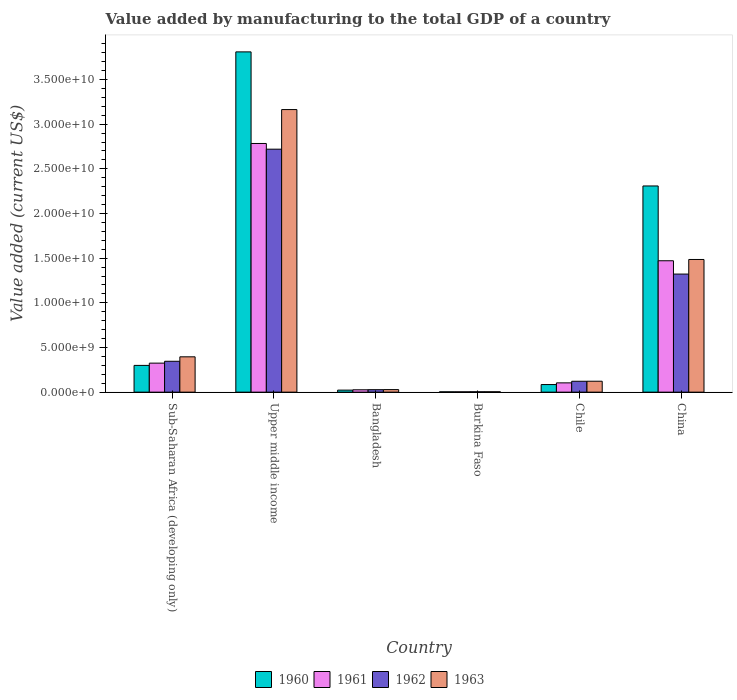How many bars are there on the 1st tick from the right?
Give a very brief answer. 4. What is the label of the 6th group of bars from the left?
Give a very brief answer. China. What is the value added by manufacturing to the total GDP in 1962 in Bangladesh?
Give a very brief answer. 2.77e+08. Across all countries, what is the maximum value added by manufacturing to the total GDP in 1960?
Your answer should be very brief. 3.81e+1. Across all countries, what is the minimum value added by manufacturing to the total GDP in 1963?
Offer a terse response. 4.39e+07. In which country was the value added by manufacturing to the total GDP in 1963 maximum?
Give a very brief answer. Upper middle income. In which country was the value added by manufacturing to the total GDP in 1963 minimum?
Make the answer very short. Burkina Faso. What is the total value added by manufacturing to the total GDP in 1962 in the graph?
Your answer should be very brief. 4.54e+1. What is the difference between the value added by manufacturing to the total GDP in 1960 in China and that in Upper middle income?
Your answer should be very brief. -1.50e+1. What is the difference between the value added by manufacturing to the total GDP in 1962 in Chile and the value added by manufacturing to the total GDP in 1961 in Burkina Faso?
Your answer should be compact. 1.18e+09. What is the average value added by manufacturing to the total GDP in 1960 per country?
Offer a terse response. 1.09e+1. What is the difference between the value added by manufacturing to the total GDP of/in 1960 and value added by manufacturing to the total GDP of/in 1962 in Bangladesh?
Provide a short and direct response. -4.99e+07. In how many countries, is the value added by manufacturing to the total GDP in 1961 greater than 21000000000 US$?
Keep it short and to the point. 1. What is the ratio of the value added by manufacturing to the total GDP in 1960 in Burkina Faso to that in China?
Your response must be concise. 0. Is the difference between the value added by manufacturing to the total GDP in 1960 in Chile and Upper middle income greater than the difference between the value added by manufacturing to the total GDP in 1962 in Chile and Upper middle income?
Your answer should be compact. No. What is the difference between the highest and the second highest value added by manufacturing to the total GDP in 1960?
Keep it short and to the point. 1.50e+1. What is the difference between the highest and the lowest value added by manufacturing to the total GDP in 1962?
Your answer should be compact. 2.72e+1. Is it the case that in every country, the sum of the value added by manufacturing to the total GDP in 1962 and value added by manufacturing to the total GDP in 1960 is greater than the sum of value added by manufacturing to the total GDP in 1961 and value added by manufacturing to the total GDP in 1963?
Your answer should be very brief. No. What does the 1st bar from the left in Bangladesh represents?
Offer a terse response. 1960. What does the 4th bar from the right in Chile represents?
Offer a terse response. 1960. How many bars are there?
Provide a succinct answer. 24. Are all the bars in the graph horizontal?
Provide a succinct answer. No. How many countries are there in the graph?
Keep it short and to the point. 6. What is the difference between two consecutive major ticks on the Y-axis?
Ensure brevity in your answer.  5.00e+09. Does the graph contain any zero values?
Offer a terse response. No. How are the legend labels stacked?
Offer a terse response. Horizontal. What is the title of the graph?
Your response must be concise. Value added by manufacturing to the total GDP of a country. What is the label or title of the X-axis?
Keep it short and to the point. Country. What is the label or title of the Y-axis?
Offer a very short reply. Value added (current US$). What is the Value added (current US$) of 1960 in Sub-Saharan Africa (developing only)?
Provide a succinct answer. 2.99e+09. What is the Value added (current US$) in 1961 in Sub-Saharan Africa (developing only)?
Offer a very short reply. 3.25e+09. What is the Value added (current US$) in 1962 in Sub-Saharan Africa (developing only)?
Make the answer very short. 3.46e+09. What is the Value added (current US$) of 1963 in Sub-Saharan Africa (developing only)?
Give a very brief answer. 3.95e+09. What is the Value added (current US$) of 1960 in Upper middle income?
Your answer should be very brief. 3.81e+1. What is the Value added (current US$) in 1961 in Upper middle income?
Ensure brevity in your answer.  2.78e+1. What is the Value added (current US$) in 1962 in Upper middle income?
Keep it short and to the point. 2.72e+1. What is the Value added (current US$) in 1963 in Upper middle income?
Make the answer very short. 3.16e+1. What is the Value added (current US$) of 1960 in Bangladesh?
Your answer should be compact. 2.27e+08. What is the Value added (current US$) of 1961 in Bangladesh?
Offer a very short reply. 2.64e+08. What is the Value added (current US$) of 1962 in Bangladesh?
Keep it short and to the point. 2.77e+08. What is the Value added (current US$) in 1963 in Bangladesh?
Keep it short and to the point. 2.85e+08. What is the Value added (current US$) in 1960 in Burkina Faso?
Offer a very short reply. 3.72e+07. What is the Value added (current US$) of 1961 in Burkina Faso?
Provide a succinct answer. 3.72e+07. What is the Value added (current US$) in 1962 in Burkina Faso?
Keep it short and to the point. 4.22e+07. What is the Value added (current US$) of 1963 in Burkina Faso?
Your answer should be compact. 4.39e+07. What is the Value added (current US$) in 1960 in Chile?
Provide a short and direct response. 8.51e+08. What is the Value added (current US$) of 1961 in Chile?
Your response must be concise. 1.04e+09. What is the Value added (current US$) of 1962 in Chile?
Ensure brevity in your answer.  1.22e+09. What is the Value added (current US$) of 1963 in Chile?
Your answer should be very brief. 1.22e+09. What is the Value added (current US$) in 1960 in China?
Offer a terse response. 2.31e+1. What is the Value added (current US$) of 1961 in China?
Your response must be concise. 1.47e+1. What is the Value added (current US$) in 1962 in China?
Give a very brief answer. 1.32e+1. What is the Value added (current US$) in 1963 in China?
Ensure brevity in your answer.  1.49e+1. Across all countries, what is the maximum Value added (current US$) in 1960?
Offer a very short reply. 3.81e+1. Across all countries, what is the maximum Value added (current US$) of 1961?
Give a very brief answer. 2.78e+1. Across all countries, what is the maximum Value added (current US$) of 1962?
Offer a very short reply. 2.72e+1. Across all countries, what is the maximum Value added (current US$) of 1963?
Offer a very short reply. 3.16e+1. Across all countries, what is the minimum Value added (current US$) in 1960?
Make the answer very short. 3.72e+07. Across all countries, what is the minimum Value added (current US$) in 1961?
Provide a succinct answer. 3.72e+07. Across all countries, what is the minimum Value added (current US$) of 1962?
Your answer should be very brief. 4.22e+07. Across all countries, what is the minimum Value added (current US$) in 1963?
Keep it short and to the point. 4.39e+07. What is the total Value added (current US$) of 1960 in the graph?
Offer a very short reply. 6.53e+1. What is the total Value added (current US$) in 1961 in the graph?
Provide a succinct answer. 4.71e+1. What is the total Value added (current US$) of 1962 in the graph?
Give a very brief answer. 4.54e+1. What is the total Value added (current US$) in 1963 in the graph?
Offer a terse response. 5.20e+1. What is the difference between the Value added (current US$) of 1960 in Sub-Saharan Africa (developing only) and that in Upper middle income?
Provide a short and direct response. -3.51e+1. What is the difference between the Value added (current US$) of 1961 in Sub-Saharan Africa (developing only) and that in Upper middle income?
Your response must be concise. -2.46e+1. What is the difference between the Value added (current US$) in 1962 in Sub-Saharan Africa (developing only) and that in Upper middle income?
Keep it short and to the point. -2.37e+1. What is the difference between the Value added (current US$) of 1963 in Sub-Saharan Africa (developing only) and that in Upper middle income?
Provide a short and direct response. -2.77e+1. What is the difference between the Value added (current US$) of 1960 in Sub-Saharan Africa (developing only) and that in Bangladesh?
Ensure brevity in your answer.  2.77e+09. What is the difference between the Value added (current US$) of 1961 in Sub-Saharan Africa (developing only) and that in Bangladesh?
Keep it short and to the point. 2.98e+09. What is the difference between the Value added (current US$) of 1962 in Sub-Saharan Africa (developing only) and that in Bangladesh?
Your answer should be very brief. 3.18e+09. What is the difference between the Value added (current US$) in 1963 in Sub-Saharan Africa (developing only) and that in Bangladesh?
Keep it short and to the point. 3.67e+09. What is the difference between the Value added (current US$) in 1960 in Sub-Saharan Africa (developing only) and that in Burkina Faso?
Keep it short and to the point. 2.96e+09. What is the difference between the Value added (current US$) in 1961 in Sub-Saharan Africa (developing only) and that in Burkina Faso?
Provide a short and direct response. 3.21e+09. What is the difference between the Value added (current US$) of 1962 in Sub-Saharan Africa (developing only) and that in Burkina Faso?
Provide a short and direct response. 3.41e+09. What is the difference between the Value added (current US$) in 1963 in Sub-Saharan Africa (developing only) and that in Burkina Faso?
Keep it short and to the point. 3.91e+09. What is the difference between the Value added (current US$) of 1960 in Sub-Saharan Africa (developing only) and that in Chile?
Provide a succinct answer. 2.14e+09. What is the difference between the Value added (current US$) of 1961 in Sub-Saharan Africa (developing only) and that in Chile?
Offer a terse response. 2.21e+09. What is the difference between the Value added (current US$) of 1962 in Sub-Saharan Africa (developing only) and that in Chile?
Provide a short and direct response. 2.24e+09. What is the difference between the Value added (current US$) in 1963 in Sub-Saharan Africa (developing only) and that in Chile?
Keep it short and to the point. 2.73e+09. What is the difference between the Value added (current US$) of 1960 in Sub-Saharan Africa (developing only) and that in China?
Offer a very short reply. -2.01e+1. What is the difference between the Value added (current US$) in 1961 in Sub-Saharan Africa (developing only) and that in China?
Your answer should be compact. -1.15e+1. What is the difference between the Value added (current US$) in 1962 in Sub-Saharan Africa (developing only) and that in China?
Offer a very short reply. -9.76e+09. What is the difference between the Value added (current US$) of 1963 in Sub-Saharan Africa (developing only) and that in China?
Give a very brief answer. -1.09e+1. What is the difference between the Value added (current US$) in 1960 in Upper middle income and that in Bangladesh?
Offer a very short reply. 3.79e+1. What is the difference between the Value added (current US$) in 1961 in Upper middle income and that in Bangladesh?
Offer a very short reply. 2.76e+1. What is the difference between the Value added (current US$) in 1962 in Upper middle income and that in Bangladesh?
Offer a very short reply. 2.69e+1. What is the difference between the Value added (current US$) in 1963 in Upper middle income and that in Bangladesh?
Make the answer very short. 3.13e+1. What is the difference between the Value added (current US$) in 1960 in Upper middle income and that in Burkina Faso?
Offer a terse response. 3.81e+1. What is the difference between the Value added (current US$) in 1961 in Upper middle income and that in Burkina Faso?
Ensure brevity in your answer.  2.78e+1. What is the difference between the Value added (current US$) of 1962 in Upper middle income and that in Burkina Faso?
Your answer should be very brief. 2.72e+1. What is the difference between the Value added (current US$) of 1963 in Upper middle income and that in Burkina Faso?
Offer a very short reply. 3.16e+1. What is the difference between the Value added (current US$) in 1960 in Upper middle income and that in Chile?
Offer a terse response. 3.72e+1. What is the difference between the Value added (current US$) in 1961 in Upper middle income and that in Chile?
Offer a very short reply. 2.68e+1. What is the difference between the Value added (current US$) in 1962 in Upper middle income and that in Chile?
Give a very brief answer. 2.60e+1. What is the difference between the Value added (current US$) in 1963 in Upper middle income and that in Chile?
Offer a terse response. 3.04e+1. What is the difference between the Value added (current US$) of 1960 in Upper middle income and that in China?
Your answer should be compact. 1.50e+1. What is the difference between the Value added (current US$) in 1961 in Upper middle income and that in China?
Make the answer very short. 1.31e+1. What is the difference between the Value added (current US$) of 1962 in Upper middle income and that in China?
Provide a short and direct response. 1.40e+1. What is the difference between the Value added (current US$) in 1963 in Upper middle income and that in China?
Keep it short and to the point. 1.68e+1. What is the difference between the Value added (current US$) of 1960 in Bangladesh and that in Burkina Faso?
Your answer should be very brief. 1.90e+08. What is the difference between the Value added (current US$) of 1961 in Bangladesh and that in Burkina Faso?
Ensure brevity in your answer.  2.26e+08. What is the difference between the Value added (current US$) of 1962 in Bangladesh and that in Burkina Faso?
Your answer should be compact. 2.35e+08. What is the difference between the Value added (current US$) in 1963 in Bangladesh and that in Burkina Faso?
Make the answer very short. 2.41e+08. What is the difference between the Value added (current US$) of 1960 in Bangladesh and that in Chile?
Make the answer very short. -6.24e+08. What is the difference between the Value added (current US$) of 1961 in Bangladesh and that in Chile?
Offer a terse response. -7.75e+08. What is the difference between the Value added (current US$) in 1962 in Bangladesh and that in Chile?
Ensure brevity in your answer.  -9.41e+08. What is the difference between the Value added (current US$) in 1963 in Bangladesh and that in Chile?
Provide a succinct answer. -9.38e+08. What is the difference between the Value added (current US$) of 1960 in Bangladesh and that in China?
Offer a terse response. -2.29e+1. What is the difference between the Value added (current US$) in 1961 in Bangladesh and that in China?
Keep it short and to the point. -1.44e+1. What is the difference between the Value added (current US$) of 1962 in Bangladesh and that in China?
Your answer should be compact. -1.29e+1. What is the difference between the Value added (current US$) of 1963 in Bangladesh and that in China?
Give a very brief answer. -1.46e+1. What is the difference between the Value added (current US$) in 1960 in Burkina Faso and that in Chile?
Provide a short and direct response. -8.13e+08. What is the difference between the Value added (current US$) in 1961 in Burkina Faso and that in Chile?
Offer a terse response. -1.00e+09. What is the difference between the Value added (current US$) in 1962 in Burkina Faso and that in Chile?
Your answer should be compact. -1.18e+09. What is the difference between the Value added (current US$) in 1963 in Burkina Faso and that in Chile?
Your answer should be very brief. -1.18e+09. What is the difference between the Value added (current US$) in 1960 in Burkina Faso and that in China?
Provide a short and direct response. -2.30e+1. What is the difference between the Value added (current US$) in 1961 in Burkina Faso and that in China?
Provide a succinct answer. -1.47e+1. What is the difference between the Value added (current US$) in 1962 in Burkina Faso and that in China?
Offer a terse response. -1.32e+1. What is the difference between the Value added (current US$) in 1963 in Burkina Faso and that in China?
Ensure brevity in your answer.  -1.48e+1. What is the difference between the Value added (current US$) in 1960 in Chile and that in China?
Your answer should be compact. -2.22e+1. What is the difference between the Value added (current US$) in 1961 in Chile and that in China?
Your answer should be very brief. -1.37e+1. What is the difference between the Value added (current US$) in 1962 in Chile and that in China?
Ensure brevity in your answer.  -1.20e+1. What is the difference between the Value added (current US$) of 1963 in Chile and that in China?
Provide a succinct answer. -1.36e+1. What is the difference between the Value added (current US$) in 1960 in Sub-Saharan Africa (developing only) and the Value added (current US$) in 1961 in Upper middle income?
Offer a very short reply. -2.48e+1. What is the difference between the Value added (current US$) in 1960 in Sub-Saharan Africa (developing only) and the Value added (current US$) in 1962 in Upper middle income?
Your answer should be very brief. -2.42e+1. What is the difference between the Value added (current US$) of 1960 in Sub-Saharan Africa (developing only) and the Value added (current US$) of 1963 in Upper middle income?
Your answer should be compact. -2.86e+1. What is the difference between the Value added (current US$) in 1961 in Sub-Saharan Africa (developing only) and the Value added (current US$) in 1962 in Upper middle income?
Your answer should be compact. -2.40e+1. What is the difference between the Value added (current US$) in 1961 in Sub-Saharan Africa (developing only) and the Value added (current US$) in 1963 in Upper middle income?
Provide a short and direct response. -2.84e+1. What is the difference between the Value added (current US$) of 1962 in Sub-Saharan Africa (developing only) and the Value added (current US$) of 1963 in Upper middle income?
Your answer should be compact. -2.82e+1. What is the difference between the Value added (current US$) of 1960 in Sub-Saharan Africa (developing only) and the Value added (current US$) of 1961 in Bangladesh?
Provide a succinct answer. 2.73e+09. What is the difference between the Value added (current US$) in 1960 in Sub-Saharan Africa (developing only) and the Value added (current US$) in 1962 in Bangladesh?
Ensure brevity in your answer.  2.72e+09. What is the difference between the Value added (current US$) in 1960 in Sub-Saharan Africa (developing only) and the Value added (current US$) in 1963 in Bangladesh?
Your response must be concise. 2.71e+09. What is the difference between the Value added (current US$) in 1961 in Sub-Saharan Africa (developing only) and the Value added (current US$) in 1962 in Bangladesh?
Offer a very short reply. 2.97e+09. What is the difference between the Value added (current US$) of 1961 in Sub-Saharan Africa (developing only) and the Value added (current US$) of 1963 in Bangladesh?
Your response must be concise. 2.96e+09. What is the difference between the Value added (current US$) in 1962 in Sub-Saharan Africa (developing only) and the Value added (current US$) in 1963 in Bangladesh?
Offer a very short reply. 3.17e+09. What is the difference between the Value added (current US$) in 1960 in Sub-Saharan Africa (developing only) and the Value added (current US$) in 1961 in Burkina Faso?
Your answer should be compact. 2.96e+09. What is the difference between the Value added (current US$) in 1960 in Sub-Saharan Africa (developing only) and the Value added (current US$) in 1962 in Burkina Faso?
Provide a short and direct response. 2.95e+09. What is the difference between the Value added (current US$) in 1960 in Sub-Saharan Africa (developing only) and the Value added (current US$) in 1963 in Burkina Faso?
Your response must be concise. 2.95e+09. What is the difference between the Value added (current US$) in 1961 in Sub-Saharan Africa (developing only) and the Value added (current US$) in 1962 in Burkina Faso?
Provide a succinct answer. 3.21e+09. What is the difference between the Value added (current US$) of 1961 in Sub-Saharan Africa (developing only) and the Value added (current US$) of 1963 in Burkina Faso?
Ensure brevity in your answer.  3.20e+09. What is the difference between the Value added (current US$) in 1962 in Sub-Saharan Africa (developing only) and the Value added (current US$) in 1963 in Burkina Faso?
Your answer should be compact. 3.41e+09. What is the difference between the Value added (current US$) of 1960 in Sub-Saharan Africa (developing only) and the Value added (current US$) of 1961 in Chile?
Offer a terse response. 1.96e+09. What is the difference between the Value added (current US$) of 1960 in Sub-Saharan Africa (developing only) and the Value added (current US$) of 1962 in Chile?
Make the answer very short. 1.78e+09. What is the difference between the Value added (current US$) in 1960 in Sub-Saharan Africa (developing only) and the Value added (current US$) in 1963 in Chile?
Offer a very short reply. 1.77e+09. What is the difference between the Value added (current US$) in 1961 in Sub-Saharan Africa (developing only) and the Value added (current US$) in 1962 in Chile?
Your answer should be very brief. 2.03e+09. What is the difference between the Value added (current US$) of 1961 in Sub-Saharan Africa (developing only) and the Value added (current US$) of 1963 in Chile?
Make the answer very short. 2.03e+09. What is the difference between the Value added (current US$) in 1962 in Sub-Saharan Africa (developing only) and the Value added (current US$) in 1963 in Chile?
Offer a very short reply. 2.23e+09. What is the difference between the Value added (current US$) of 1960 in Sub-Saharan Africa (developing only) and the Value added (current US$) of 1961 in China?
Your response must be concise. -1.17e+1. What is the difference between the Value added (current US$) in 1960 in Sub-Saharan Africa (developing only) and the Value added (current US$) in 1962 in China?
Ensure brevity in your answer.  -1.02e+1. What is the difference between the Value added (current US$) in 1960 in Sub-Saharan Africa (developing only) and the Value added (current US$) in 1963 in China?
Your answer should be very brief. -1.19e+1. What is the difference between the Value added (current US$) in 1961 in Sub-Saharan Africa (developing only) and the Value added (current US$) in 1962 in China?
Make the answer very short. -9.97e+09. What is the difference between the Value added (current US$) in 1961 in Sub-Saharan Africa (developing only) and the Value added (current US$) in 1963 in China?
Offer a very short reply. -1.16e+1. What is the difference between the Value added (current US$) in 1962 in Sub-Saharan Africa (developing only) and the Value added (current US$) in 1963 in China?
Provide a succinct answer. -1.14e+1. What is the difference between the Value added (current US$) in 1960 in Upper middle income and the Value added (current US$) in 1961 in Bangladesh?
Offer a terse response. 3.78e+1. What is the difference between the Value added (current US$) in 1960 in Upper middle income and the Value added (current US$) in 1962 in Bangladesh?
Give a very brief answer. 3.78e+1. What is the difference between the Value added (current US$) in 1960 in Upper middle income and the Value added (current US$) in 1963 in Bangladesh?
Ensure brevity in your answer.  3.78e+1. What is the difference between the Value added (current US$) in 1961 in Upper middle income and the Value added (current US$) in 1962 in Bangladesh?
Provide a succinct answer. 2.76e+1. What is the difference between the Value added (current US$) in 1961 in Upper middle income and the Value added (current US$) in 1963 in Bangladesh?
Your response must be concise. 2.76e+1. What is the difference between the Value added (current US$) of 1962 in Upper middle income and the Value added (current US$) of 1963 in Bangladesh?
Your response must be concise. 2.69e+1. What is the difference between the Value added (current US$) of 1960 in Upper middle income and the Value added (current US$) of 1961 in Burkina Faso?
Make the answer very short. 3.81e+1. What is the difference between the Value added (current US$) in 1960 in Upper middle income and the Value added (current US$) in 1962 in Burkina Faso?
Provide a succinct answer. 3.80e+1. What is the difference between the Value added (current US$) of 1960 in Upper middle income and the Value added (current US$) of 1963 in Burkina Faso?
Offer a very short reply. 3.80e+1. What is the difference between the Value added (current US$) in 1961 in Upper middle income and the Value added (current US$) in 1962 in Burkina Faso?
Provide a succinct answer. 2.78e+1. What is the difference between the Value added (current US$) of 1961 in Upper middle income and the Value added (current US$) of 1963 in Burkina Faso?
Make the answer very short. 2.78e+1. What is the difference between the Value added (current US$) in 1962 in Upper middle income and the Value added (current US$) in 1963 in Burkina Faso?
Provide a succinct answer. 2.72e+1. What is the difference between the Value added (current US$) of 1960 in Upper middle income and the Value added (current US$) of 1961 in Chile?
Make the answer very short. 3.71e+1. What is the difference between the Value added (current US$) in 1960 in Upper middle income and the Value added (current US$) in 1962 in Chile?
Your answer should be very brief. 3.69e+1. What is the difference between the Value added (current US$) in 1960 in Upper middle income and the Value added (current US$) in 1963 in Chile?
Offer a terse response. 3.69e+1. What is the difference between the Value added (current US$) of 1961 in Upper middle income and the Value added (current US$) of 1962 in Chile?
Ensure brevity in your answer.  2.66e+1. What is the difference between the Value added (current US$) in 1961 in Upper middle income and the Value added (current US$) in 1963 in Chile?
Give a very brief answer. 2.66e+1. What is the difference between the Value added (current US$) of 1962 in Upper middle income and the Value added (current US$) of 1963 in Chile?
Provide a succinct answer. 2.60e+1. What is the difference between the Value added (current US$) of 1960 in Upper middle income and the Value added (current US$) of 1961 in China?
Keep it short and to the point. 2.34e+1. What is the difference between the Value added (current US$) in 1960 in Upper middle income and the Value added (current US$) in 1962 in China?
Your answer should be compact. 2.49e+1. What is the difference between the Value added (current US$) of 1960 in Upper middle income and the Value added (current US$) of 1963 in China?
Make the answer very short. 2.32e+1. What is the difference between the Value added (current US$) of 1961 in Upper middle income and the Value added (current US$) of 1962 in China?
Provide a succinct answer. 1.46e+1. What is the difference between the Value added (current US$) of 1961 in Upper middle income and the Value added (current US$) of 1963 in China?
Give a very brief answer. 1.30e+1. What is the difference between the Value added (current US$) of 1962 in Upper middle income and the Value added (current US$) of 1963 in China?
Provide a succinct answer. 1.23e+1. What is the difference between the Value added (current US$) of 1960 in Bangladesh and the Value added (current US$) of 1961 in Burkina Faso?
Keep it short and to the point. 1.90e+08. What is the difference between the Value added (current US$) of 1960 in Bangladesh and the Value added (current US$) of 1962 in Burkina Faso?
Give a very brief answer. 1.85e+08. What is the difference between the Value added (current US$) in 1960 in Bangladesh and the Value added (current US$) in 1963 in Burkina Faso?
Keep it short and to the point. 1.83e+08. What is the difference between the Value added (current US$) of 1961 in Bangladesh and the Value added (current US$) of 1962 in Burkina Faso?
Offer a very short reply. 2.21e+08. What is the difference between the Value added (current US$) of 1961 in Bangladesh and the Value added (current US$) of 1963 in Burkina Faso?
Ensure brevity in your answer.  2.20e+08. What is the difference between the Value added (current US$) in 1962 in Bangladesh and the Value added (current US$) in 1963 in Burkina Faso?
Provide a short and direct response. 2.33e+08. What is the difference between the Value added (current US$) of 1960 in Bangladesh and the Value added (current US$) of 1961 in Chile?
Make the answer very short. -8.12e+08. What is the difference between the Value added (current US$) of 1960 in Bangladesh and the Value added (current US$) of 1962 in Chile?
Your answer should be very brief. -9.91e+08. What is the difference between the Value added (current US$) of 1960 in Bangladesh and the Value added (current US$) of 1963 in Chile?
Offer a terse response. -9.96e+08. What is the difference between the Value added (current US$) in 1961 in Bangladesh and the Value added (current US$) in 1962 in Chile?
Keep it short and to the point. -9.55e+08. What is the difference between the Value added (current US$) in 1961 in Bangladesh and the Value added (current US$) in 1963 in Chile?
Ensure brevity in your answer.  -9.59e+08. What is the difference between the Value added (current US$) of 1962 in Bangladesh and the Value added (current US$) of 1963 in Chile?
Provide a succinct answer. -9.46e+08. What is the difference between the Value added (current US$) of 1960 in Bangladesh and the Value added (current US$) of 1961 in China?
Make the answer very short. -1.45e+1. What is the difference between the Value added (current US$) of 1960 in Bangladesh and the Value added (current US$) of 1962 in China?
Make the answer very short. -1.30e+1. What is the difference between the Value added (current US$) of 1960 in Bangladesh and the Value added (current US$) of 1963 in China?
Offer a terse response. -1.46e+1. What is the difference between the Value added (current US$) in 1961 in Bangladesh and the Value added (current US$) in 1962 in China?
Ensure brevity in your answer.  -1.30e+1. What is the difference between the Value added (current US$) in 1961 in Bangladesh and the Value added (current US$) in 1963 in China?
Ensure brevity in your answer.  -1.46e+1. What is the difference between the Value added (current US$) in 1962 in Bangladesh and the Value added (current US$) in 1963 in China?
Offer a very short reply. -1.46e+1. What is the difference between the Value added (current US$) of 1960 in Burkina Faso and the Value added (current US$) of 1961 in Chile?
Make the answer very short. -1.00e+09. What is the difference between the Value added (current US$) of 1960 in Burkina Faso and the Value added (current US$) of 1962 in Chile?
Your response must be concise. -1.18e+09. What is the difference between the Value added (current US$) of 1960 in Burkina Faso and the Value added (current US$) of 1963 in Chile?
Keep it short and to the point. -1.19e+09. What is the difference between the Value added (current US$) in 1961 in Burkina Faso and the Value added (current US$) in 1962 in Chile?
Your response must be concise. -1.18e+09. What is the difference between the Value added (current US$) of 1961 in Burkina Faso and the Value added (current US$) of 1963 in Chile?
Provide a short and direct response. -1.19e+09. What is the difference between the Value added (current US$) of 1962 in Burkina Faso and the Value added (current US$) of 1963 in Chile?
Your answer should be very brief. -1.18e+09. What is the difference between the Value added (current US$) in 1960 in Burkina Faso and the Value added (current US$) in 1961 in China?
Offer a very short reply. -1.47e+1. What is the difference between the Value added (current US$) of 1960 in Burkina Faso and the Value added (current US$) of 1962 in China?
Your answer should be compact. -1.32e+1. What is the difference between the Value added (current US$) in 1960 in Burkina Faso and the Value added (current US$) in 1963 in China?
Keep it short and to the point. -1.48e+1. What is the difference between the Value added (current US$) in 1961 in Burkina Faso and the Value added (current US$) in 1962 in China?
Give a very brief answer. -1.32e+1. What is the difference between the Value added (current US$) in 1961 in Burkina Faso and the Value added (current US$) in 1963 in China?
Provide a short and direct response. -1.48e+1. What is the difference between the Value added (current US$) in 1962 in Burkina Faso and the Value added (current US$) in 1963 in China?
Your response must be concise. -1.48e+1. What is the difference between the Value added (current US$) in 1960 in Chile and the Value added (current US$) in 1961 in China?
Offer a very short reply. -1.39e+1. What is the difference between the Value added (current US$) of 1960 in Chile and the Value added (current US$) of 1962 in China?
Provide a succinct answer. -1.24e+1. What is the difference between the Value added (current US$) in 1960 in Chile and the Value added (current US$) in 1963 in China?
Ensure brevity in your answer.  -1.40e+1. What is the difference between the Value added (current US$) in 1961 in Chile and the Value added (current US$) in 1962 in China?
Your response must be concise. -1.22e+1. What is the difference between the Value added (current US$) in 1961 in Chile and the Value added (current US$) in 1963 in China?
Provide a succinct answer. -1.38e+1. What is the difference between the Value added (current US$) of 1962 in Chile and the Value added (current US$) of 1963 in China?
Your answer should be compact. -1.36e+1. What is the average Value added (current US$) in 1960 per country?
Provide a short and direct response. 1.09e+1. What is the average Value added (current US$) of 1961 per country?
Offer a very short reply. 7.86e+09. What is the average Value added (current US$) in 1962 per country?
Keep it short and to the point. 7.57e+09. What is the average Value added (current US$) in 1963 per country?
Keep it short and to the point. 8.67e+09. What is the difference between the Value added (current US$) in 1960 and Value added (current US$) in 1961 in Sub-Saharan Africa (developing only)?
Offer a terse response. -2.54e+08. What is the difference between the Value added (current US$) in 1960 and Value added (current US$) in 1962 in Sub-Saharan Africa (developing only)?
Your answer should be compact. -4.61e+08. What is the difference between the Value added (current US$) of 1960 and Value added (current US$) of 1963 in Sub-Saharan Africa (developing only)?
Ensure brevity in your answer.  -9.61e+08. What is the difference between the Value added (current US$) of 1961 and Value added (current US$) of 1962 in Sub-Saharan Africa (developing only)?
Ensure brevity in your answer.  -2.08e+08. What is the difference between the Value added (current US$) in 1961 and Value added (current US$) in 1963 in Sub-Saharan Africa (developing only)?
Keep it short and to the point. -7.07e+08. What is the difference between the Value added (current US$) in 1962 and Value added (current US$) in 1963 in Sub-Saharan Africa (developing only)?
Your answer should be very brief. -4.99e+08. What is the difference between the Value added (current US$) of 1960 and Value added (current US$) of 1961 in Upper middle income?
Make the answer very short. 1.03e+1. What is the difference between the Value added (current US$) in 1960 and Value added (current US$) in 1962 in Upper middle income?
Ensure brevity in your answer.  1.09e+1. What is the difference between the Value added (current US$) in 1960 and Value added (current US$) in 1963 in Upper middle income?
Make the answer very short. 6.46e+09. What is the difference between the Value added (current US$) in 1961 and Value added (current US$) in 1962 in Upper middle income?
Your answer should be very brief. 6.38e+08. What is the difference between the Value added (current US$) in 1961 and Value added (current US$) in 1963 in Upper middle income?
Keep it short and to the point. -3.80e+09. What is the difference between the Value added (current US$) of 1962 and Value added (current US$) of 1963 in Upper middle income?
Provide a succinct answer. -4.43e+09. What is the difference between the Value added (current US$) in 1960 and Value added (current US$) in 1961 in Bangladesh?
Provide a short and direct response. -3.66e+07. What is the difference between the Value added (current US$) of 1960 and Value added (current US$) of 1962 in Bangladesh?
Offer a terse response. -4.99e+07. What is the difference between the Value added (current US$) in 1960 and Value added (current US$) in 1963 in Bangladesh?
Your answer should be very brief. -5.81e+07. What is the difference between the Value added (current US$) of 1961 and Value added (current US$) of 1962 in Bangladesh?
Provide a succinct answer. -1.33e+07. What is the difference between the Value added (current US$) of 1961 and Value added (current US$) of 1963 in Bangladesh?
Ensure brevity in your answer.  -2.15e+07. What is the difference between the Value added (current US$) of 1962 and Value added (current US$) of 1963 in Bangladesh?
Keep it short and to the point. -8.22e+06. What is the difference between the Value added (current US$) of 1960 and Value added (current US$) of 1961 in Burkina Faso?
Provide a short and direct response. 9866.11. What is the difference between the Value added (current US$) of 1960 and Value added (current US$) of 1962 in Burkina Faso?
Ensure brevity in your answer.  -5.00e+06. What is the difference between the Value added (current US$) in 1960 and Value added (current US$) in 1963 in Burkina Faso?
Your response must be concise. -6.65e+06. What is the difference between the Value added (current US$) of 1961 and Value added (current US$) of 1962 in Burkina Faso?
Your answer should be very brief. -5.01e+06. What is the difference between the Value added (current US$) of 1961 and Value added (current US$) of 1963 in Burkina Faso?
Your answer should be very brief. -6.66e+06. What is the difference between the Value added (current US$) in 1962 and Value added (current US$) in 1963 in Burkina Faso?
Offer a terse response. -1.65e+06. What is the difference between the Value added (current US$) in 1960 and Value added (current US$) in 1961 in Chile?
Keep it short and to the point. -1.88e+08. What is the difference between the Value added (current US$) of 1960 and Value added (current US$) of 1962 in Chile?
Offer a very short reply. -3.68e+08. What is the difference between the Value added (current US$) of 1960 and Value added (current US$) of 1963 in Chile?
Offer a very short reply. -3.72e+08. What is the difference between the Value added (current US$) in 1961 and Value added (current US$) in 1962 in Chile?
Keep it short and to the point. -1.80e+08. What is the difference between the Value added (current US$) in 1961 and Value added (current US$) in 1963 in Chile?
Provide a short and direct response. -1.84e+08. What is the difference between the Value added (current US$) in 1962 and Value added (current US$) in 1963 in Chile?
Give a very brief answer. -4.28e+06. What is the difference between the Value added (current US$) of 1960 and Value added (current US$) of 1961 in China?
Your answer should be very brief. 8.37e+09. What is the difference between the Value added (current US$) of 1960 and Value added (current US$) of 1962 in China?
Provide a short and direct response. 9.86e+09. What is the difference between the Value added (current US$) of 1960 and Value added (current US$) of 1963 in China?
Give a very brief answer. 8.23e+09. What is the difference between the Value added (current US$) in 1961 and Value added (current US$) in 1962 in China?
Offer a terse response. 1.49e+09. What is the difference between the Value added (current US$) of 1961 and Value added (current US$) of 1963 in China?
Provide a short and direct response. -1.42e+08. What is the difference between the Value added (current US$) in 1962 and Value added (current US$) in 1963 in China?
Your response must be concise. -1.63e+09. What is the ratio of the Value added (current US$) in 1960 in Sub-Saharan Africa (developing only) to that in Upper middle income?
Your answer should be very brief. 0.08. What is the ratio of the Value added (current US$) of 1961 in Sub-Saharan Africa (developing only) to that in Upper middle income?
Make the answer very short. 0.12. What is the ratio of the Value added (current US$) in 1962 in Sub-Saharan Africa (developing only) to that in Upper middle income?
Provide a short and direct response. 0.13. What is the ratio of the Value added (current US$) of 1960 in Sub-Saharan Africa (developing only) to that in Bangladesh?
Offer a terse response. 13.19. What is the ratio of the Value added (current US$) in 1961 in Sub-Saharan Africa (developing only) to that in Bangladesh?
Ensure brevity in your answer.  12.32. What is the ratio of the Value added (current US$) of 1962 in Sub-Saharan Africa (developing only) to that in Bangladesh?
Make the answer very short. 12.48. What is the ratio of the Value added (current US$) of 1963 in Sub-Saharan Africa (developing only) to that in Bangladesh?
Offer a terse response. 13.87. What is the ratio of the Value added (current US$) in 1960 in Sub-Saharan Africa (developing only) to that in Burkina Faso?
Offer a terse response. 80.43. What is the ratio of the Value added (current US$) of 1961 in Sub-Saharan Africa (developing only) to that in Burkina Faso?
Give a very brief answer. 87.26. What is the ratio of the Value added (current US$) in 1962 in Sub-Saharan Africa (developing only) to that in Burkina Faso?
Give a very brief answer. 81.83. What is the ratio of the Value added (current US$) in 1963 in Sub-Saharan Africa (developing only) to that in Burkina Faso?
Your answer should be compact. 90.13. What is the ratio of the Value added (current US$) of 1960 in Sub-Saharan Africa (developing only) to that in Chile?
Ensure brevity in your answer.  3.52. What is the ratio of the Value added (current US$) in 1961 in Sub-Saharan Africa (developing only) to that in Chile?
Ensure brevity in your answer.  3.13. What is the ratio of the Value added (current US$) in 1962 in Sub-Saharan Africa (developing only) to that in Chile?
Offer a terse response. 2.84. What is the ratio of the Value added (current US$) of 1963 in Sub-Saharan Africa (developing only) to that in Chile?
Offer a very short reply. 3.23. What is the ratio of the Value added (current US$) of 1960 in Sub-Saharan Africa (developing only) to that in China?
Your answer should be compact. 0.13. What is the ratio of the Value added (current US$) of 1961 in Sub-Saharan Africa (developing only) to that in China?
Give a very brief answer. 0.22. What is the ratio of the Value added (current US$) in 1962 in Sub-Saharan Africa (developing only) to that in China?
Offer a terse response. 0.26. What is the ratio of the Value added (current US$) in 1963 in Sub-Saharan Africa (developing only) to that in China?
Offer a terse response. 0.27. What is the ratio of the Value added (current US$) of 1960 in Upper middle income to that in Bangladesh?
Keep it short and to the point. 167.8. What is the ratio of the Value added (current US$) in 1961 in Upper middle income to that in Bangladesh?
Provide a succinct answer. 105.62. What is the ratio of the Value added (current US$) of 1962 in Upper middle income to that in Bangladesh?
Your answer should be compact. 98.24. What is the ratio of the Value added (current US$) of 1963 in Upper middle income to that in Bangladesh?
Ensure brevity in your answer.  110.96. What is the ratio of the Value added (current US$) of 1960 in Upper middle income to that in Burkina Faso?
Your response must be concise. 1023.17. What is the ratio of the Value added (current US$) of 1961 in Upper middle income to that in Burkina Faso?
Provide a short and direct response. 747.95. What is the ratio of the Value added (current US$) in 1962 in Upper middle income to that in Burkina Faso?
Make the answer very short. 644.09. What is the ratio of the Value added (current US$) in 1963 in Upper middle income to that in Burkina Faso?
Offer a terse response. 720.87. What is the ratio of the Value added (current US$) of 1960 in Upper middle income to that in Chile?
Ensure brevity in your answer.  44.77. What is the ratio of the Value added (current US$) of 1961 in Upper middle income to that in Chile?
Keep it short and to the point. 26.8. What is the ratio of the Value added (current US$) of 1962 in Upper middle income to that in Chile?
Your response must be concise. 22.32. What is the ratio of the Value added (current US$) in 1963 in Upper middle income to that in Chile?
Offer a very short reply. 25.87. What is the ratio of the Value added (current US$) in 1960 in Upper middle income to that in China?
Your answer should be very brief. 1.65. What is the ratio of the Value added (current US$) in 1961 in Upper middle income to that in China?
Provide a short and direct response. 1.89. What is the ratio of the Value added (current US$) of 1962 in Upper middle income to that in China?
Keep it short and to the point. 2.06. What is the ratio of the Value added (current US$) in 1963 in Upper middle income to that in China?
Your answer should be very brief. 2.13. What is the ratio of the Value added (current US$) of 1960 in Bangladesh to that in Burkina Faso?
Provide a short and direct response. 6.1. What is the ratio of the Value added (current US$) in 1961 in Bangladesh to that in Burkina Faso?
Give a very brief answer. 7.08. What is the ratio of the Value added (current US$) in 1962 in Bangladesh to that in Burkina Faso?
Ensure brevity in your answer.  6.56. What is the ratio of the Value added (current US$) of 1963 in Bangladesh to that in Burkina Faso?
Ensure brevity in your answer.  6.5. What is the ratio of the Value added (current US$) in 1960 in Bangladesh to that in Chile?
Ensure brevity in your answer.  0.27. What is the ratio of the Value added (current US$) of 1961 in Bangladesh to that in Chile?
Provide a succinct answer. 0.25. What is the ratio of the Value added (current US$) in 1962 in Bangladesh to that in Chile?
Offer a terse response. 0.23. What is the ratio of the Value added (current US$) in 1963 in Bangladesh to that in Chile?
Your answer should be compact. 0.23. What is the ratio of the Value added (current US$) of 1960 in Bangladesh to that in China?
Ensure brevity in your answer.  0.01. What is the ratio of the Value added (current US$) in 1961 in Bangladesh to that in China?
Ensure brevity in your answer.  0.02. What is the ratio of the Value added (current US$) in 1962 in Bangladesh to that in China?
Offer a terse response. 0.02. What is the ratio of the Value added (current US$) of 1963 in Bangladesh to that in China?
Provide a short and direct response. 0.02. What is the ratio of the Value added (current US$) in 1960 in Burkina Faso to that in Chile?
Provide a short and direct response. 0.04. What is the ratio of the Value added (current US$) in 1961 in Burkina Faso to that in Chile?
Offer a terse response. 0.04. What is the ratio of the Value added (current US$) of 1962 in Burkina Faso to that in Chile?
Your answer should be very brief. 0.03. What is the ratio of the Value added (current US$) in 1963 in Burkina Faso to that in Chile?
Your answer should be compact. 0.04. What is the ratio of the Value added (current US$) of 1960 in Burkina Faso to that in China?
Give a very brief answer. 0. What is the ratio of the Value added (current US$) of 1961 in Burkina Faso to that in China?
Offer a terse response. 0. What is the ratio of the Value added (current US$) in 1962 in Burkina Faso to that in China?
Your answer should be compact. 0. What is the ratio of the Value added (current US$) of 1963 in Burkina Faso to that in China?
Your answer should be compact. 0. What is the ratio of the Value added (current US$) in 1960 in Chile to that in China?
Your answer should be compact. 0.04. What is the ratio of the Value added (current US$) in 1961 in Chile to that in China?
Your answer should be very brief. 0.07. What is the ratio of the Value added (current US$) in 1962 in Chile to that in China?
Offer a terse response. 0.09. What is the ratio of the Value added (current US$) in 1963 in Chile to that in China?
Provide a short and direct response. 0.08. What is the difference between the highest and the second highest Value added (current US$) of 1960?
Your answer should be compact. 1.50e+1. What is the difference between the highest and the second highest Value added (current US$) of 1961?
Ensure brevity in your answer.  1.31e+1. What is the difference between the highest and the second highest Value added (current US$) of 1962?
Offer a terse response. 1.40e+1. What is the difference between the highest and the second highest Value added (current US$) in 1963?
Your answer should be very brief. 1.68e+1. What is the difference between the highest and the lowest Value added (current US$) of 1960?
Make the answer very short. 3.81e+1. What is the difference between the highest and the lowest Value added (current US$) of 1961?
Provide a short and direct response. 2.78e+1. What is the difference between the highest and the lowest Value added (current US$) in 1962?
Offer a terse response. 2.72e+1. What is the difference between the highest and the lowest Value added (current US$) of 1963?
Provide a short and direct response. 3.16e+1. 